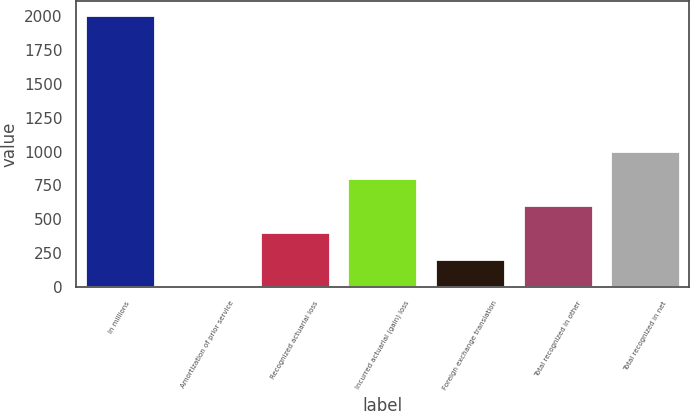Convert chart to OTSL. <chart><loc_0><loc_0><loc_500><loc_500><bar_chart><fcel>In millions<fcel>Amortization of prior service<fcel>Recognized actuarial loss<fcel>Incurred actuarial (gain) loss<fcel>Foreign exchange translation<fcel>Total recognized in other<fcel>Total recognized in net<nl><fcel>2012<fcel>1<fcel>403.2<fcel>805.4<fcel>202.1<fcel>604.3<fcel>1006.5<nl></chart> 